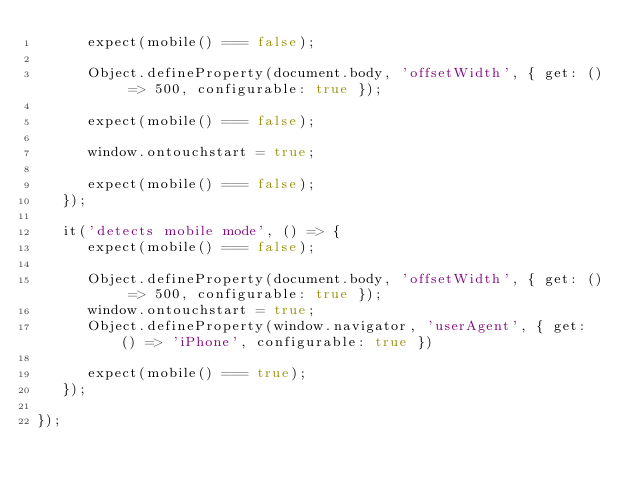<code> <loc_0><loc_0><loc_500><loc_500><_JavaScript_>      expect(mobile() === false);

      Object.defineProperty(document.body, 'offsetWidth', { get: () => 500, configurable: true });

      expect(mobile() === false);

      window.ontouchstart = true;

      expect(mobile() === false);
   });

   it('detects mobile mode', () => {
      expect(mobile() === false);

      Object.defineProperty(document.body, 'offsetWidth', { get: () => 500, configurable: true });
      window.ontouchstart = true;
      Object.defineProperty(window.navigator, 'userAgent', { get: () => 'iPhone', configurable: true })

      expect(mobile() === true);
   });

});</code> 